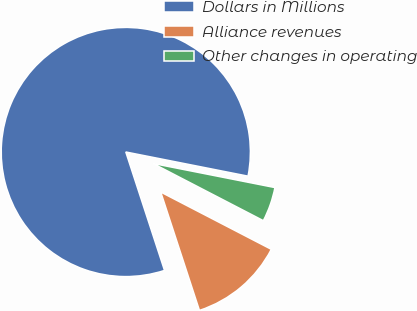<chart> <loc_0><loc_0><loc_500><loc_500><pie_chart><fcel>Dollars in Millions<fcel>Alliance revenues<fcel>Other changes in operating<nl><fcel>83.13%<fcel>12.36%<fcel>4.5%<nl></chart> 